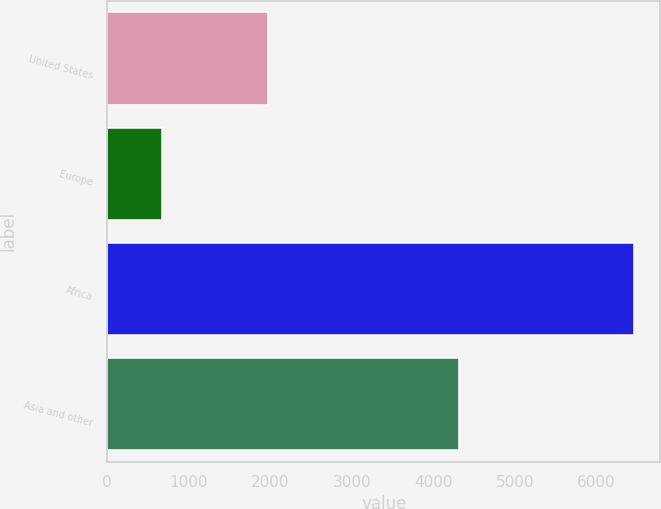Convert chart to OTSL. <chart><loc_0><loc_0><loc_500><loc_500><bar_chart><fcel>United States<fcel>Europe<fcel>Africa<fcel>Asia and other<nl><fcel>1971<fcel>673<fcel>6464<fcel>4323<nl></chart> 